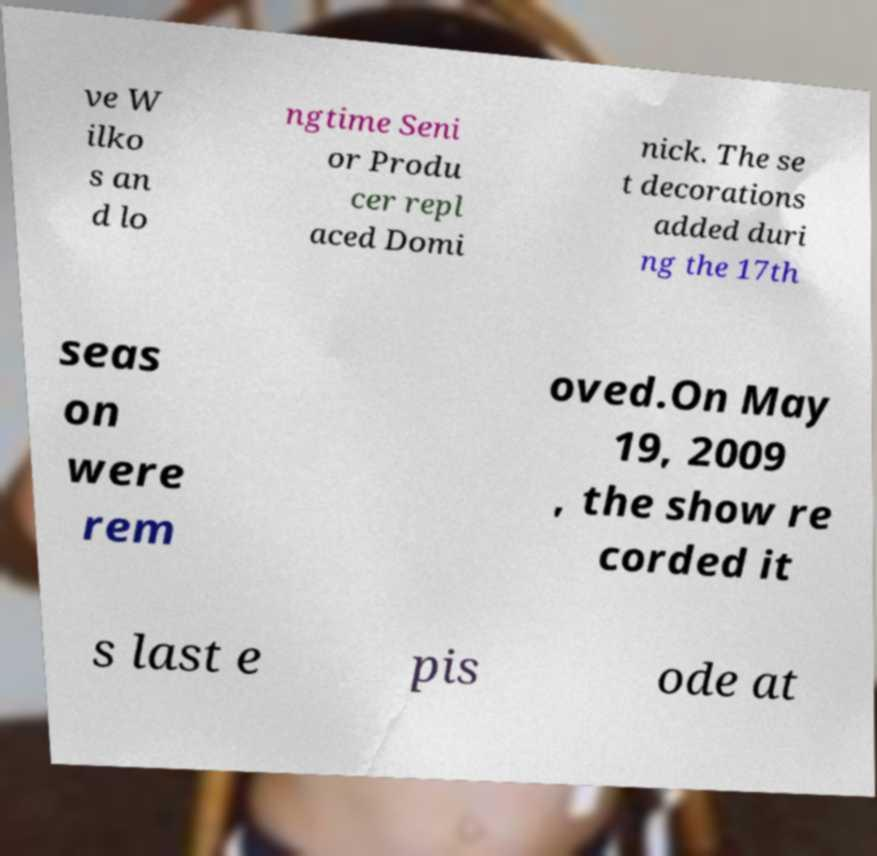Could you extract and type out the text from this image? ve W ilko s an d lo ngtime Seni or Produ cer repl aced Domi nick. The se t decorations added duri ng the 17th seas on were rem oved.On May 19, 2009 , the show re corded it s last e pis ode at 